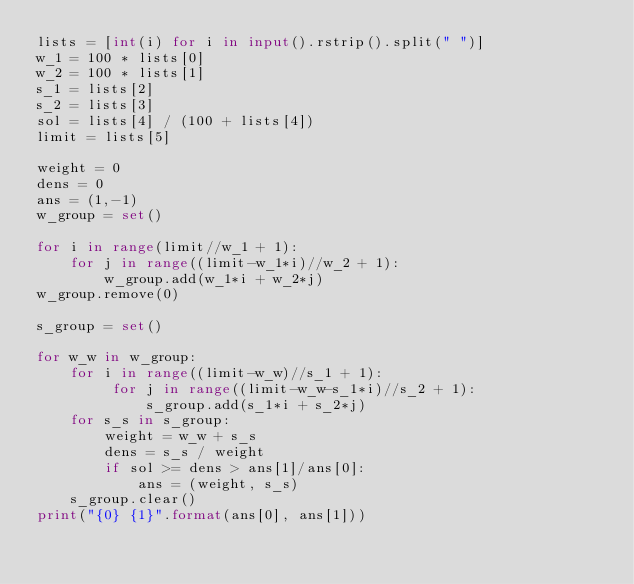Convert code to text. <code><loc_0><loc_0><loc_500><loc_500><_Python_>lists = [int(i) for i in input().rstrip().split(" ")]
w_1 = 100 * lists[0]
w_2 = 100 * lists[1]
s_1 = lists[2]
s_2 = lists[3]
sol = lists[4] / (100 + lists[4])
limit = lists[5]

weight = 0
dens = 0
ans = (1,-1)
w_group = set()

for i in range(limit//w_1 + 1):
    for j in range((limit-w_1*i)//w_2 + 1):
        w_group.add(w_1*i + w_2*j)
w_group.remove(0)

s_group = set()

for w_w in w_group:
    for i in range((limit-w_w)//s_1 + 1):
         for j in range((limit-w_w-s_1*i)//s_2 + 1):
             s_group.add(s_1*i + s_2*j)
    for s_s in s_group:
        weight = w_w + s_s
        dens = s_s / weight
        if sol >= dens > ans[1]/ans[0]:
            ans = (weight, s_s)
    s_group.clear()
print("{0} {1}".format(ans[0], ans[1]))</code> 